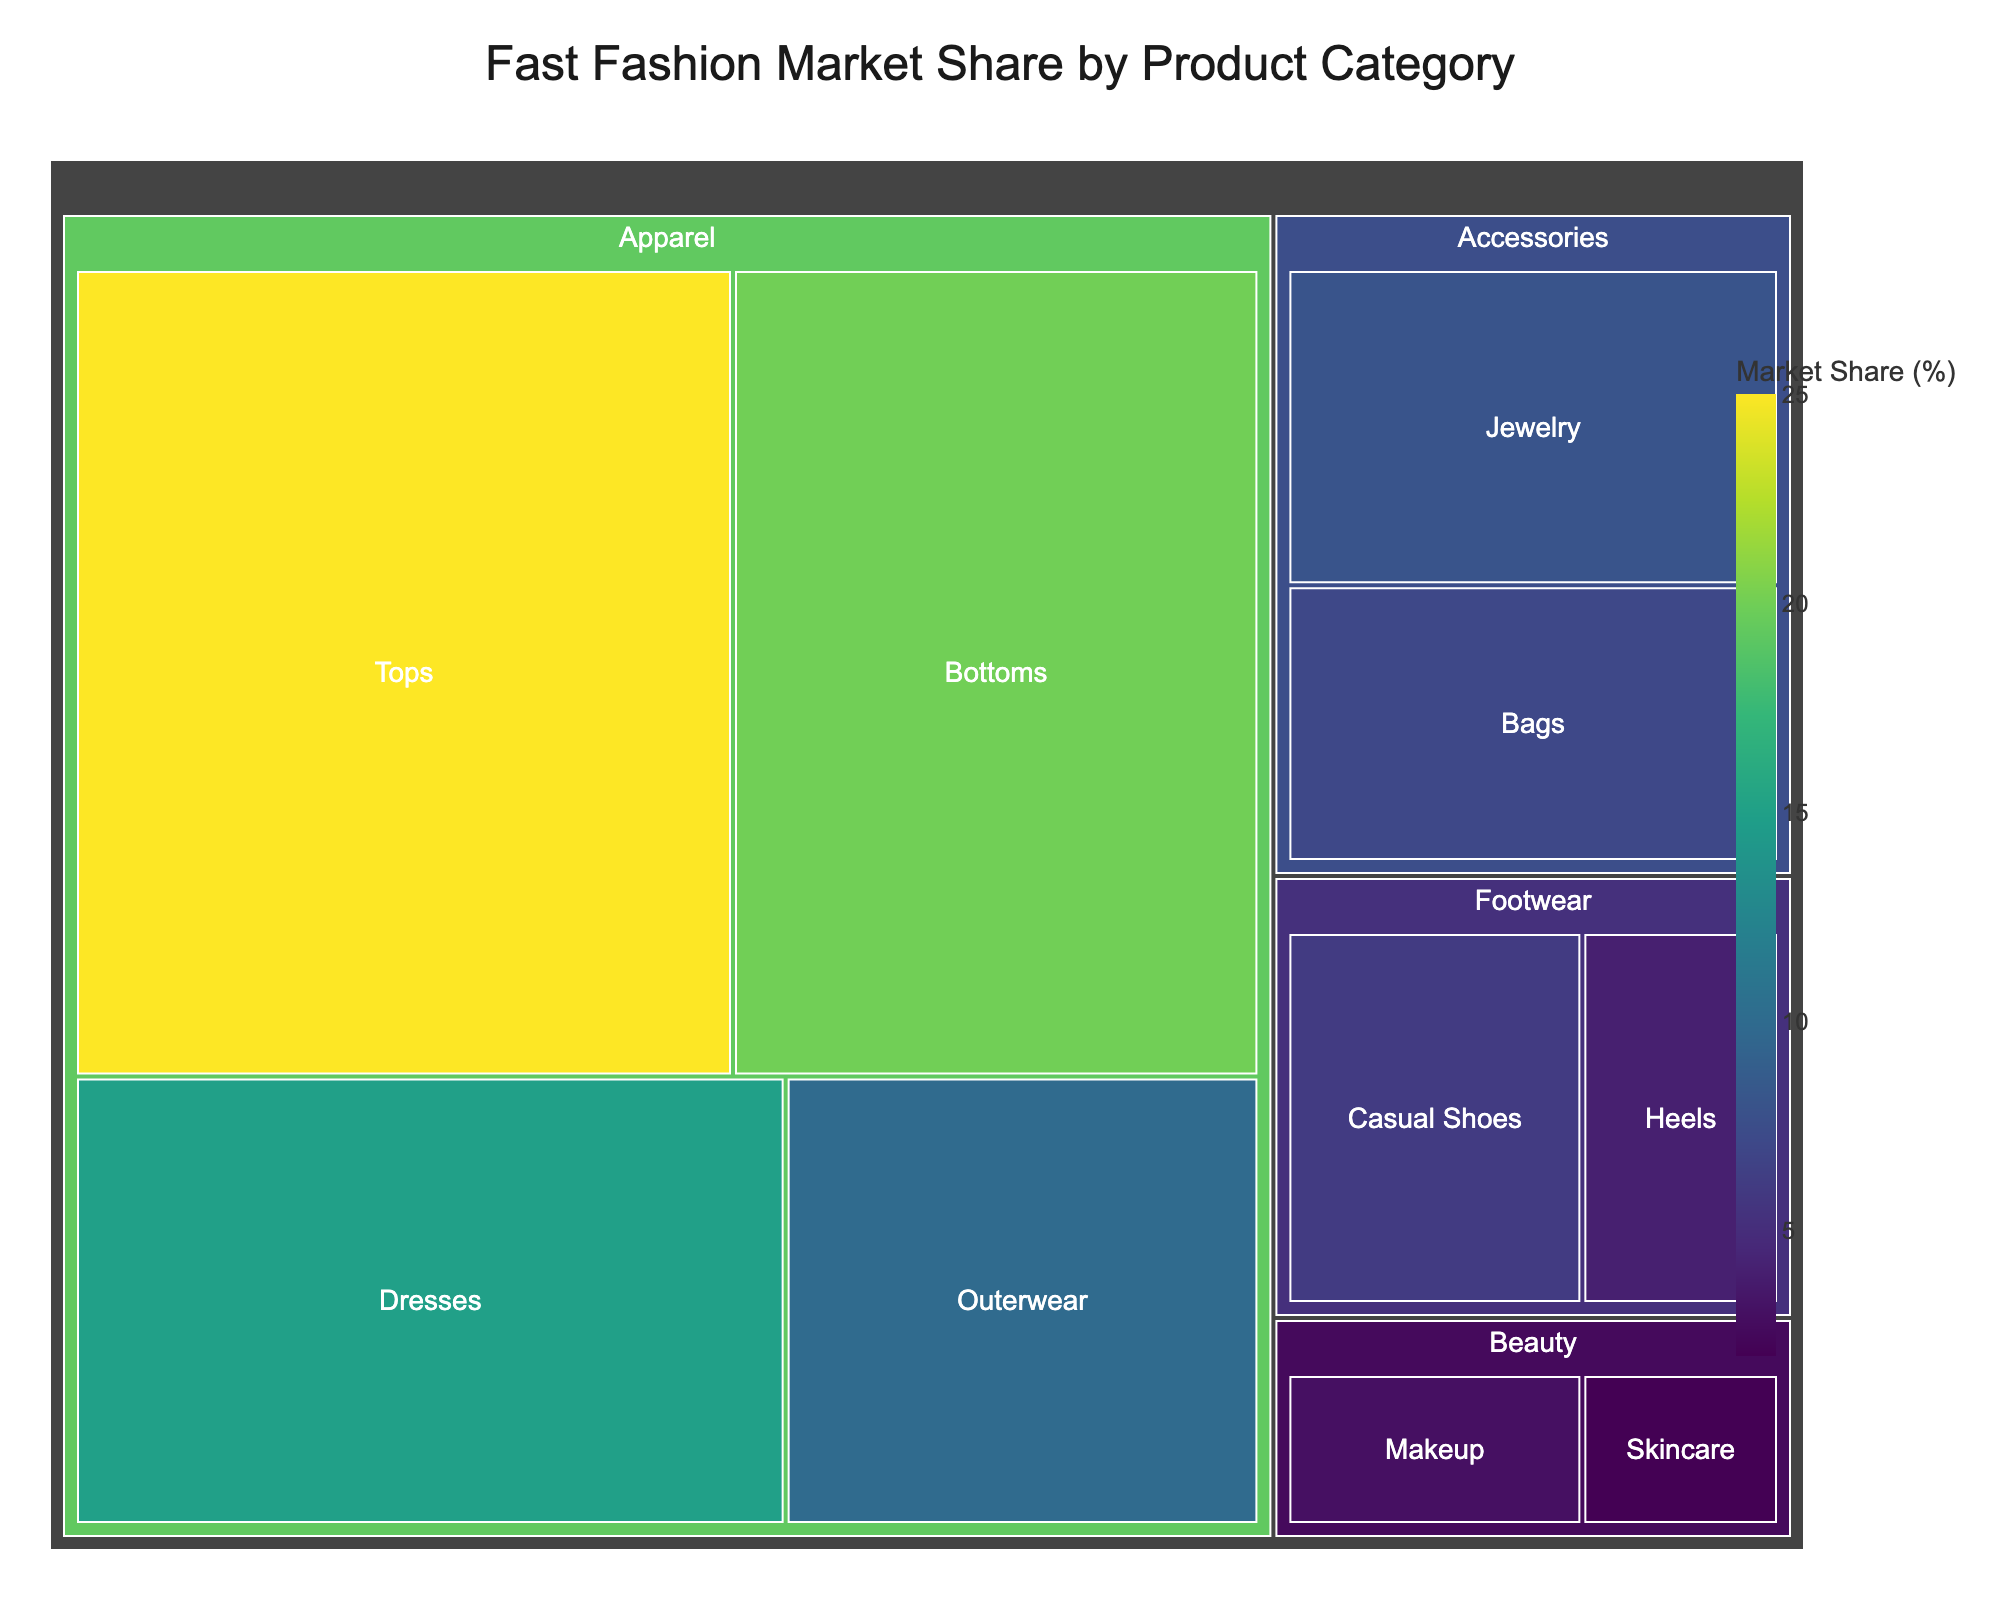What is the title of the figure? The title of the figure is displayed prominently at the top. It reads "Fast Fashion Market Share by Product Category".
Answer: Fast Fashion Market Share by Product Category Which subcategory has the largest market share? By examining the treemap, the largest block represents "Tops" under the "Apparel" category, with a market share of 25%.
Answer: Tops What is the market share of the "Beauty" category? Adding the market shares of "Makeup" (3%) and "Skincare" (2%) subcategories gives the total market share for "Beauty".
Answer: 5% How do the market shares of "Outerwear" and "Casual Shoes" compare? "Outerwear" has a market share of 10%, while "Casual Shoes" has 6%. Therefore, "Outerwear" has a larger market share.
Answer: Outerwear is larger What is the combined market share of "Jewelry" and "Bags"? Summing the market shares of "Jewelry" (8%) and "Bags" (7%) gives a total of 15%.
Answer: 15% Which category has the smallest market share? "Skincare" under the "Beauty" category has the smallest market share at 2%.
Answer: Skincare How does the market share of "Heels" compare to "Bottoms"? "Bottoms" has a market share of 20%, while "Heels" has 4%. "Bottoms" has a significantly larger market share.
Answer: Bottoms What is the difference in market share between "Apparel" and "Accessories"? The total market share of "Apparel" is 70% (25 + 20 + 15 + 10). "Accessories" is 15% (8 + 7). The difference is 70% - 15% = 55%.
Answer: 55% What proportion of the total market is made up by "Footwear"? Adding the market shares of "Casual Shoes" (6%) and "Heels" (4%) gives the total market share for "Footwear" as 10%.
Answer: 10% How are the subcategories of "Apparel" visually represented compared to other categories? "Apparel" subcategories such as "Tops," "Bottoms," "Dresses," and "Outerwear" are larger in size and occupy a bigger area of the treemap, indicating a higher combined market share compared to other categories like "Accessories," "Footwear," and "Beauty".
Answer: Larger visual representation 